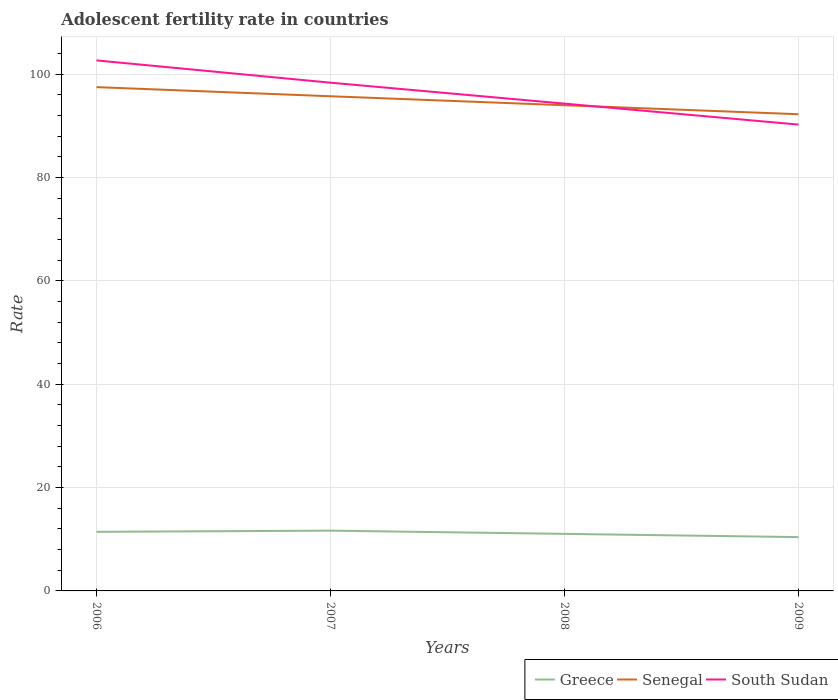How many different coloured lines are there?
Give a very brief answer. 3. Across all years, what is the maximum adolescent fertility rate in South Sudan?
Give a very brief answer. 90.23. In which year was the adolescent fertility rate in South Sudan maximum?
Provide a short and direct response. 2009. What is the total adolescent fertility rate in Greece in the graph?
Offer a terse response. 0.39. What is the difference between the highest and the second highest adolescent fertility rate in Senegal?
Provide a short and direct response. 5.24. What is the difference between the highest and the lowest adolescent fertility rate in Greece?
Your answer should be very brief. 2. Is the adolescent fertility rate in Greece strictly greater than the adolescent fertility rate in South Sudan over the years?
Provide a succinct answer. Yes. How many years are there in the graph?
Provide a succinct answer. 4. Where does the legend appear in the graph?
Offer a very short reply. Bottom right. How are the legend labels stacked?
Your response must be concise. Horizontal. What is the title of the graph?
Your response must be concise. Adolescent fertility rate in countries. Does "Dominica" appear as one of the legend labels in the graph?
Ensure brevity in your answer.  No. What is the label or title of the X-axis?
Your response must be concise. Years. What is the label or title of the Y-axis?
Your answer should be compact. Rate. What is the Rate in Greece in 2006?
Give a very brief answer. 11.43. What is the Rate in Senegal in 2006?
Keep it short and to the point. 97.48. What is the Rate of South Sudan in 2006?
Your response must be concise. 102.64. What is the Rate of Greece in 2007?
Keep it short and to the point. 11.66. What is the Rate in Senegal in 2007?
Provide a short and direct response. 95.71. What is the Rate of South Sudan in 2007?
Ensure brevity in your answer.  98.34. What is the Rate of Greece in 2008?
Offer a terse response. 11.04. What is the Rate of Senegal in 2008?
Your answer should be very brief. 93.97. What is the Rate of South Sudan in 2008?
Offer a very short reply. 94.28. What is the Rate of Greece in 2009?
Offer a very short reply. 10.41. What is the Rate of Senegal in 2009?
Your answer should be compact. 92.23. What is the Rate in South Sudan in 2009?
Ensure brevity in your answer.  90.23. Across all years, what is the maximum Rate in Greece?
Offer a terse response. 11.66. Across all years, what is the maximum Rate of Senegal?
Give a very brief answer. 97.48. Across all years, what is the maximum Rate of South Sudan?
Offer a terse response. 102.64. Across all years, what is the minimum Rate in Greece?
Provide a short and direct response. 10.41. Across all years, what is the minimum Rate of Senegal?
Provide a short and direct response. 92.23. Across all years, what is the minimum Rate of South Sudan?
Your response must be concise. 90.23. What is the total Rate in Greece in the graph?
Give a very brief answer. 44.55. What is the total Rate of Senegal in the graph?
Make the answer very short. 379.39. What is the total Rate in South Sudan in the graph?
Keep it short and to the point. 385.5. What is the difference between the Rate of Greece in 2006 and that in 2007?
Make the answer very short. -0.23. What is the difference between the Rate in Senegal in 2006 and that in 2007?
Make the answer very short. 1.77. What is the difference between the Rate of South Sudan in 2006 and that in 2007?
Ensure brevity in your answer.  4.31. What is the difference between the Rate of Greece in 2006 and that in 2008?
Your answer should be very brief. 0.39. What is the difference between the Rate of Senegal in 2006 and that in 2008?
Provide a short and direct response. 3.5. What is the difference between the Rate in South Sudan in 2006 and that in 2008?
Your response must be concise. 8.36. What is the difference between the Rate of Greece in 2006 and that in 2009?
Keep it short and to the point. 1.02. What is the difference between the Rate of Senegal in 2006 and that in 2009?
Make the answer very short. 5.24. What is the difference between the Rate in South Sudan in 2006 and that in 2009?
Provide a succinct answer. 12.41. What is the difference between the Rate in Greece in 2007 and that in 2008?
Keep it short and to the point. 0.62. What is the difference between the Rate of Senegal in 2007 and that in 2008?
Your response must be concise. 1.74. What is the difference between the Rate in South Sudan in 2007 and that in 2008?
Provide a succinct answer. 4.05. What is the difference between the Rate of Greece in 2007 and that in 2009?
Your response must be concise. 1.25. What is the difference between the Rate of Senegal in 2007 and that in 2009?
Your answer should be compact. 3.48. What is the difference between the Rate of South Sudan in 2007 and that in 2009?
Give a very brief answer. 8.1. What is the difference between the Rate of Greece in 2008 and that in 2009?
Your answer should be compact. 0.62. What is the difference between the Rate of Senegal in 2008 and that in 2009?
Keep it short and to the point. 1.74. What is the difference between the Rate of South Sudan in 2008 and that in 2009?
Provide a short and direct response. 4.05. What is the difference between the Rate in Greece in 2006 and the Rate in Senegal in 2007?
Your response must be concise. -84.28. What is the difference between the Rate in Greece in 2006 and the Rate in South Sudan in 2007?
Your answer should be compact. -86.9. What is the difference between the Rate of Senegal in 2006 and the Rate of South Sudan in 2007?
Provide a succinct answer. -0.86. What is the difference between the Rate in Greece in 2006 and the Rate in Senegal in 2008?
Keep it short and to the point. -82.54. What is the difference between the Rate in Greece in 2006 and the Rate in South Sudan in 2008?
Your answer should be compact. -82.85. What is the difference between the Rate of Senegal in 2006 and the Rate of South Sudan in 2008?
Offer a very short reply. 3.19. What is the difference between the Rate of Greece in 2006 and the Rate of Senegal in 2009?
Provide a succinct answer. -80.8. What is the difference between the Rate of Greece in 2006 and the Rate of South Sudan in 2009?
Make the answer very short. -78.8. What is the difference between the Rate in Senegal in 2006 and the Rate in South Sudan in 2009?
Your answer should be compact. 7.24. What is the difference between the Rate of Greece in 2007 and the Rate of Senegal in 2008?
Your answer should be compact. -82.31. What is the difference between the Rate in Greece in 2007 and the Rate in South Sudan in 2008?
Offer a terse response. -82.62. What is the difference between the Rate of Senegal in 2007 and the Rate of South Sudan in 2008?
Give a very brief answer. 1.43. What is the difference between the Rate in Greece in 2007 and the Rate in Senegal in 2009?
Provide a short and direct response. -80.57. What is the difference between the Rate of Greece in 2007 and the Rate of South Sudan in 2009?
Offer a terse response. -78.57. What is the difference between the Rate of Senegal in 2007 and the Rate of South Sudan in 2009?
Ensure brevity in your answer.  5.48. What is the difference between the Rate of Greece in 2008 and the Rate of Senegal in 2009?
Your answer should be compact. -81.19. What is the difference between the Rate in Greece in 2008 and the Rate in South Sudan in 2009?
Offer a very short reply. -79.19. What is the difference between the Rate in Senegal in 2008 and the Rate in South Sudan in 2009?
Your answer should be very brief. 3.74. What is the average Rate of Greece per year?
Keep it short and to the point. 11.14. What is the average Rate of Senegal per year?
Offer a terse response. 94.85. What is the average Rate of South Sudan per year?
Provide a succinct answer. 96.37. In the year 2006, what is the difference between the Rate of Greece and Rate of Senegal?
Provide a short and direct response. -86.04. In the year 2006, what is the difference between the Rate of Greece and Rate of South Sudan?
Offer a terse response. -91.21. In the year 2006, what is the difference between the Rate of Senegal and Rate of South Sudan?
Your response must be concise. -5.17. In the year 2007, what is the difference between the Rate of Greece and Rate of Senegal?
Your answer should be compact. -84.05. In the year 2007, what is the difference between the Rate of Greece and Rate of South Sudan?
Your answer should be compact. -86.67. In the year 2007, what is the difference between the Rate of Senegal and Rate of South Sudan?
Your answer should be very brief. -2.63. In the year 2008, what is the difference between the Rate in Greece and Rate in Senegal?
Offer a terse response. -82.93. In the year 2008, what is the difference between the Rate in Greece and Rate in South Sudan?
Your response must be concise. -83.25. In the year 2008, what is the difference between the Rate in Senegal and Rate in South Sudan?
Give a very brief answer. -0.31. In the year 2009, what is the difference between the Rate of Greece and Rate of Senegal?
Your answer should be very brief. -81.82. In the year 2009, what is the difference between the Rate in Greece and Rate in South Sudan?
Provide a succinct answer. -79.82. In the year 2009, what is the difference between the Rate in Senegal and Rate in South Sudan?
Keep it short and to the point. 2. What is the ratio of the Rate in Greece in 2006 to that in 2007?
Offer a terse response. 0.98. What is the ratio of the Rate in Senegal in 2006 to that in 2007?
Your response must be concise. 1.02. What is the ratio of the Rate in South Sudan in 2006 to that in 2007?
Keep it short and to the point. 1.04. What is the ratio of the Rate of Greece in 2006 to that in 2008?
Provide a succinct answer. 1.04. What is the ratio of the Rate of Senegal in 2006 to that in 2008?
Offer a terse response. 1.04. What is the ratio of the Rate in South Sudan in 2006 to that in 2008?
Your answer should be very brief. 1.09. What is the ratio of the Rate in Greece in 2006 to that in 2009?
Make the answer very short. 1.1. What is the ratio of the Rate of Senegal in 2006 to that in 2009?
Offer a very short reply. 1.06. What is the ratio of the Rate in South Sudan in 2006 to that in 2009?
Keep it short and to the point. 1.14. What is the ratio of the Rate of Greece in 2007 to that in 2008?
Offer a very short reply. 1.06. What is the ratio of the Rate in Senegal in 2007 to that in 2008?
Your answer should be compact. 1.02. What is the ratio of the Rate of South Sudan in 2007 to that in 2008?
Your answer should be very brief. 1.04. What is the ratio of the Rate of Greece in 2007 to that in 2009?
Offer a very short reply. 1.12. What is the ratio of the Rate of Senegal in 2007 to that in 2009?
Make the answer very short. 1.04. What is the ratio of the Rate in South Sudan in 2007 to that in 2009?
Your answer should be very brief. 1.09. What is the ratio of the Rate of Greece in 2008 to that in 2009?
Your answer should be compact. 1.06. What is the ratio of the Rate of Senegal in 2008 to that in 2009?
Give a very brief answer. 1.02. What is the ratio of the Rate in South Sudan in 2008 to that in 2009?
Your answer should be very brief. 1.04. What is the difference between the highest and the second highest Rate in Greece?
Ensure brevity in your answer.  0.23. What is the difference between the highest and the second highest Rate in Senegal?
Make the answer very short. 1.77. What is the difference between the highest and the second highest Rate in South Sudan?
Offer a terse response. 4.31. What is the difference between the highest and the lowest Rate of Greece?
Make the answer very short. 1.25. What is the difference between the highest and the lowest Rate of Senegal?
Make the answer very short. 5.24. What is the difference between the highest and the lowest Rate in South Sudan?
Keep it short and to the point. 12.41. 